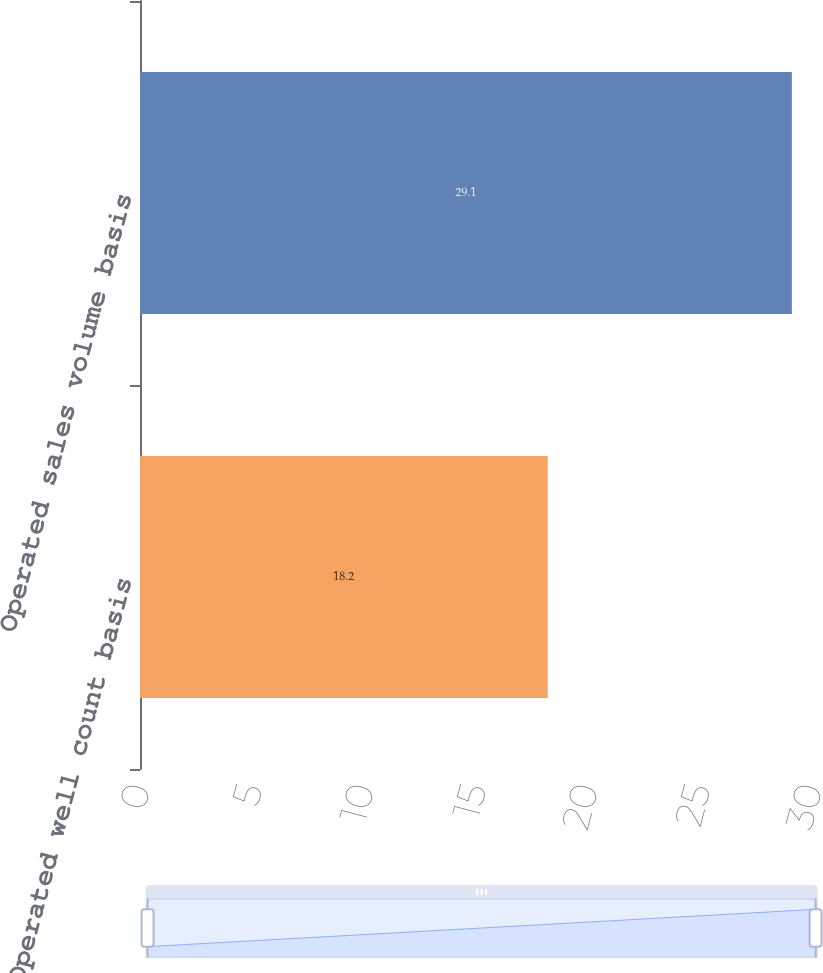Convert chart to OTSL. <chart><loc_0><loc_0><loc_500><loc_500><bar_chart><fcel>Operated well count basis<fcel>Operated sales volume basis<nl><fcel>18.2<fcel>29.1<nl></chart> 